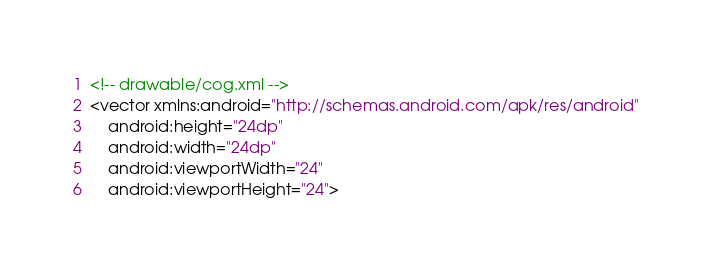Convert code to text. <code><loc_0><loc_0><loc_500><loc_500><_XML_><!-- drawable/cog.xml -->
<vector xmlns:android="http://schemas.android.com/apk/res/android"
    android:height="24dp"
    android:width="24dp"
    android:viewportWidth="24"
    android:viewportHeight="24"></code> 